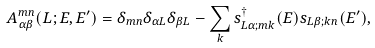Convert formula to latex. <formula><loc_0><loc_0><loc_500><loc_500>A _ { \alpha \beta } ^ { m n } ( L ; E , E ^ { \prime } ) = \delta _ { m n } \delta _ { \alpha L } \delta _ { \beta L } - \sum _ { k } s ^ { \dagger } _ { L \alpha ; m k } ( E ) s _ { L \beta ; k n } ( E ^ { \prime } ) ,</formula> 